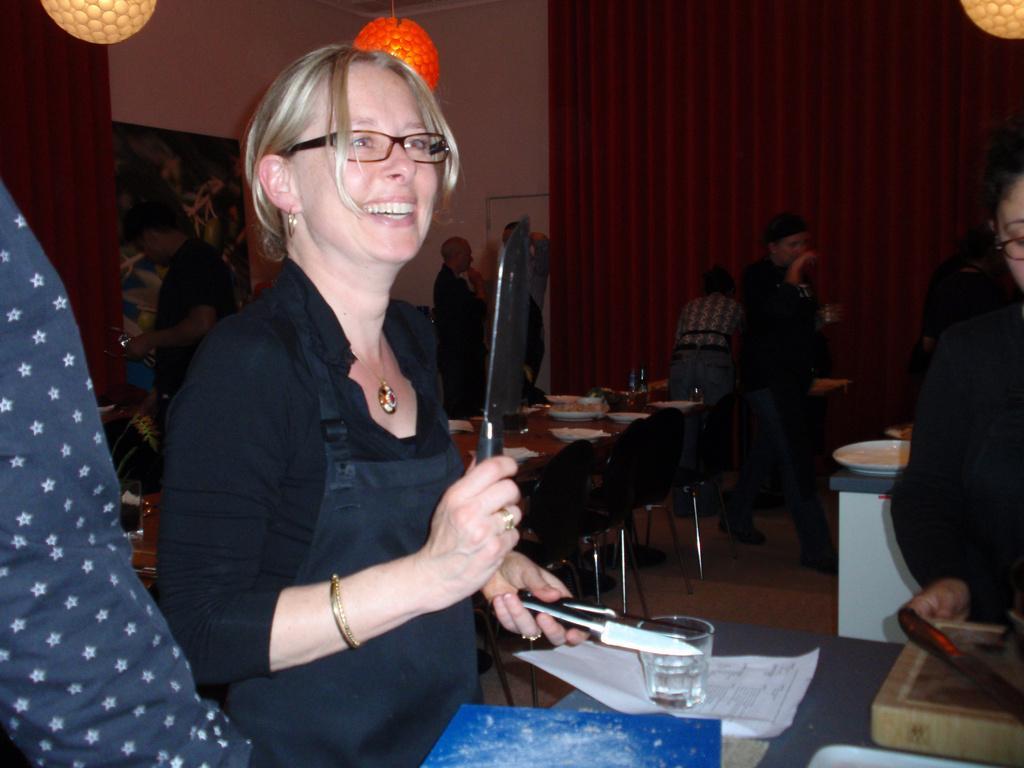Please provide a concise description of this image. In this picture, there is a woman towards the left. She is wearing a black shirt and holding knives in her hands. Before her, there is a table. On the table, there are books, papers and a bowl. Towards the right, there is another person. Behind them, there is a table surrounded by the chairs. On the table, there are bowls with food. In the background, there are people, wall, curtain and lights. 